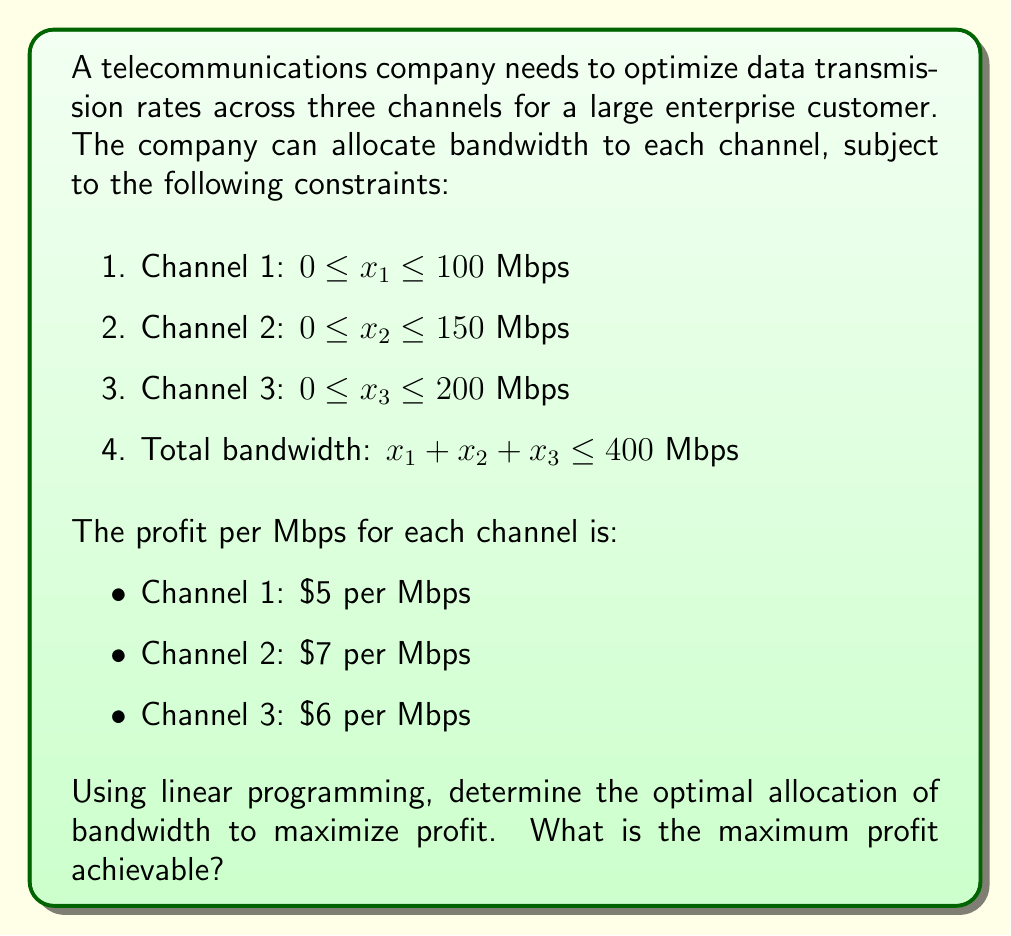Could you help me with this problem? To solve this linear programming problem, we'll follow these steps:

1. Define the objective function:
   Maximize $Z = 5x_1 + 7x_2 + 6x_3$

2. List the constraints:
   $0 \leq x_1 \leq 100$
   $0 \leq x_2 \leq 150$
   $0 \leq x_3 \leq 200$
   $x_1 + x_2 + x_3 \leq 400$

3. Solve using the simplex method or graphical method. In this case, we can use intuition due to the nature of the problem:

   - Channel 2 has the highest profit per Mbps ($7), so we allocate the maximum to it first: $x_2 = 150$
   - Channel 3 has the second-highest profit ($6), so we allocate as much as possible: $x_3 = 200$
   - The remaining bandwidth is allocated to Channel 1: $x_1 = 400 - 150 - 200 = 50$

4. Calculate the maximum profit:
   $Z = 5(50) + 7(150) + 6(200)$
   $Z = 250 + 1050 + 1200$
   $Z = 2500$

Therefore, the optimal allocation is:
- Channel 1: 50 Mbps
- Channel 2: 150 Mbps
- Channel 3: 200 Mbps

This allocation maximizes the profit.
Answer: $2500 